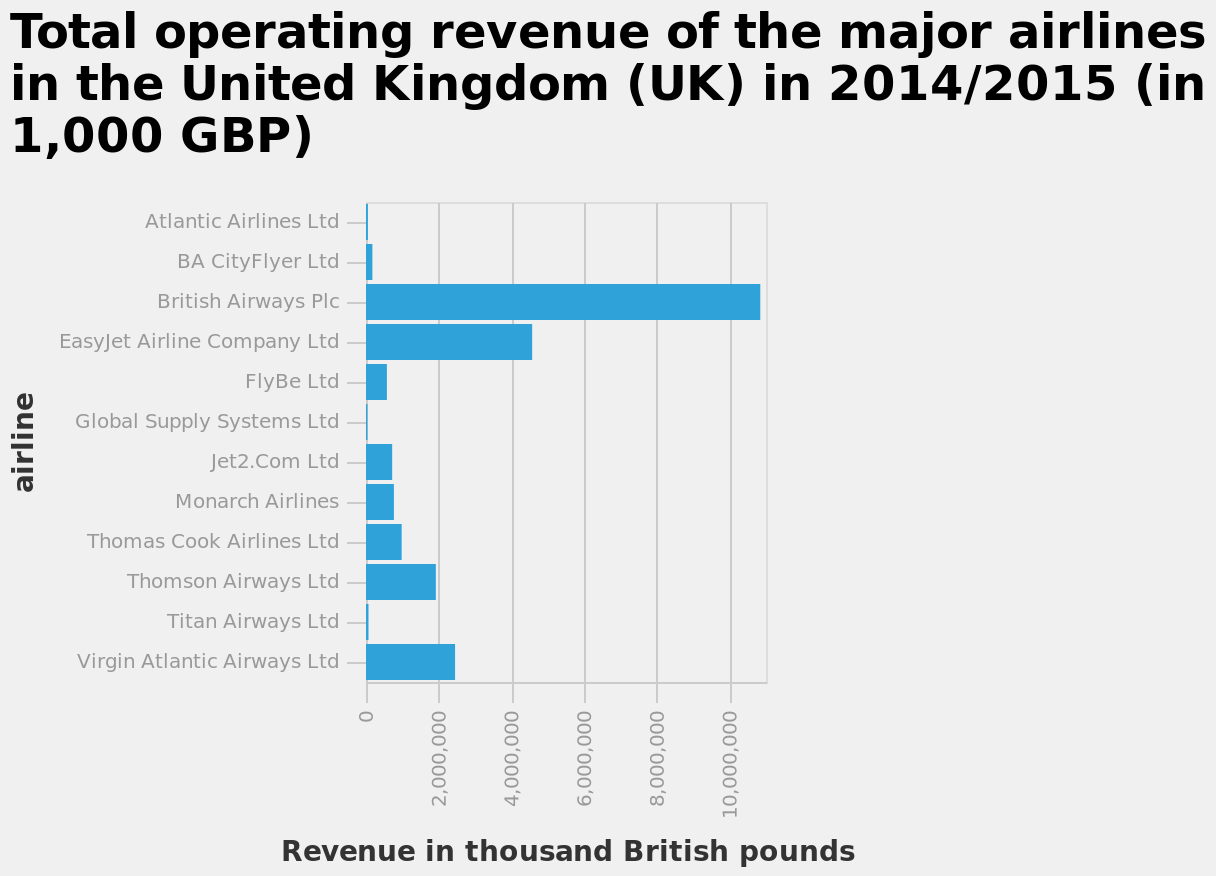<image>
How does Easyjet's revenue compare to British Airways? Easyjet's revenue is roughly half of British Airways' revenue. Is British Airways the operator with the most revenue? Yes, British Airways has far more revenue than any other operator. 